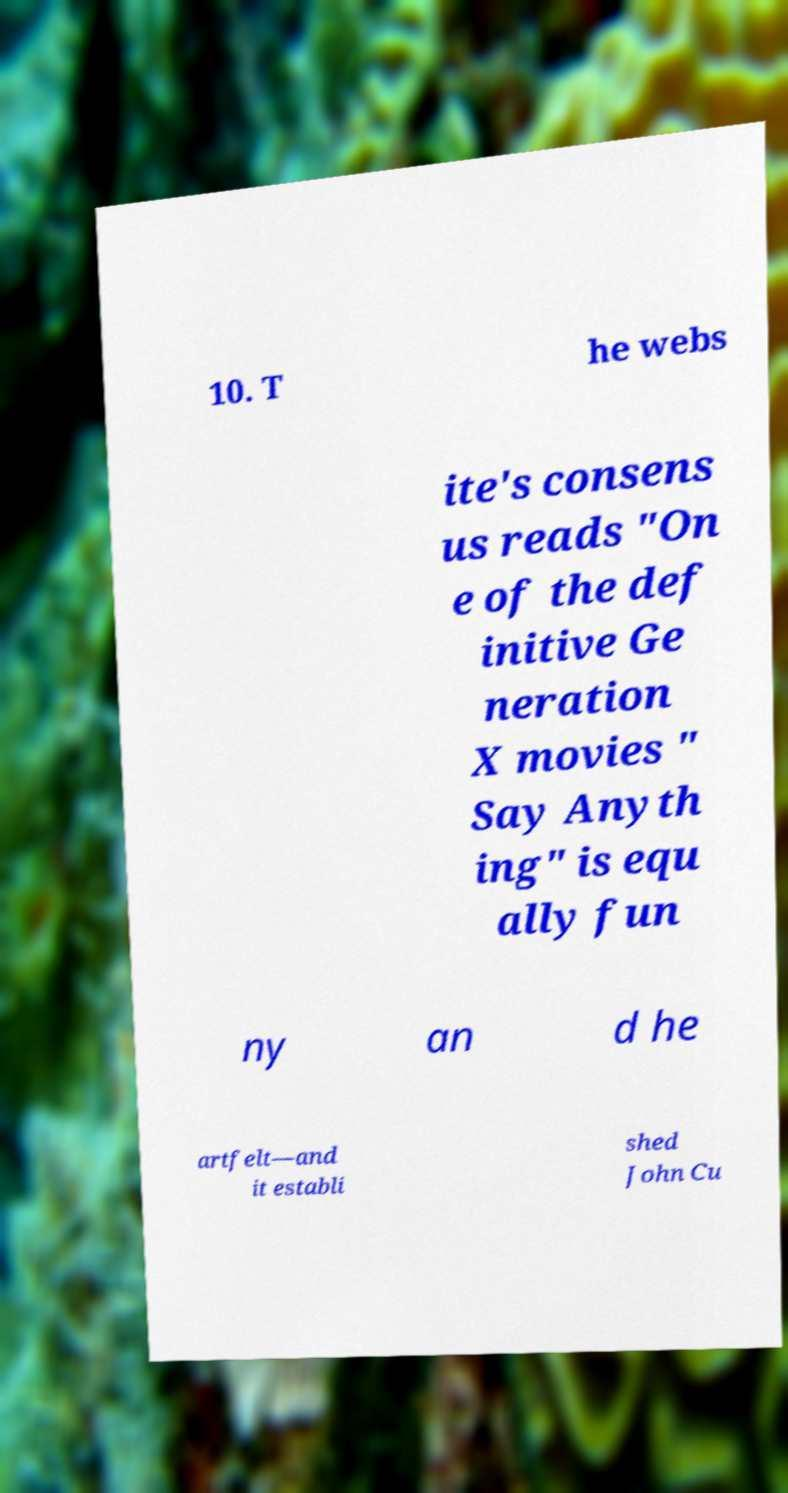Could you assist in decoding the text presented in this image and type it out clearly? 10. T he webs ite's consens us reads "On e of the def initive Ge neration X movies " Say Anyth ing" is equ ally fun ny an d he artfelt—and it establi shed John Cu 